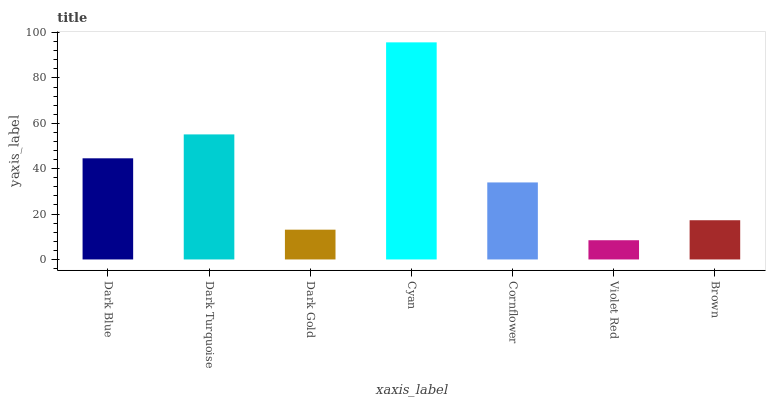Is Dark Turquoise the minimum?
Answer yes or no. No. Is Dark Turquoise the maximum?
Answer yes or no. No. Is Dark Turquoise greater than Dark Blue?
Answer yes or no. Yes. Is Dark Blue less than Dark Turquoise?
Answer yes or no. Yes. Is Dark Blue greater than Dark Turquoise?
Answer yes or no. No. Is Dark Turquoise less than Dark Blue?
Answer yes or no. No. Is Cornflower the high median?
Answer yes or no. Yes. Is Cornflower the low median?
Answer yes or no. Yes. Is Cyan the high median?
Answer yes or no. No. Is Violet Red the low median?
Answer yes or no. No. 